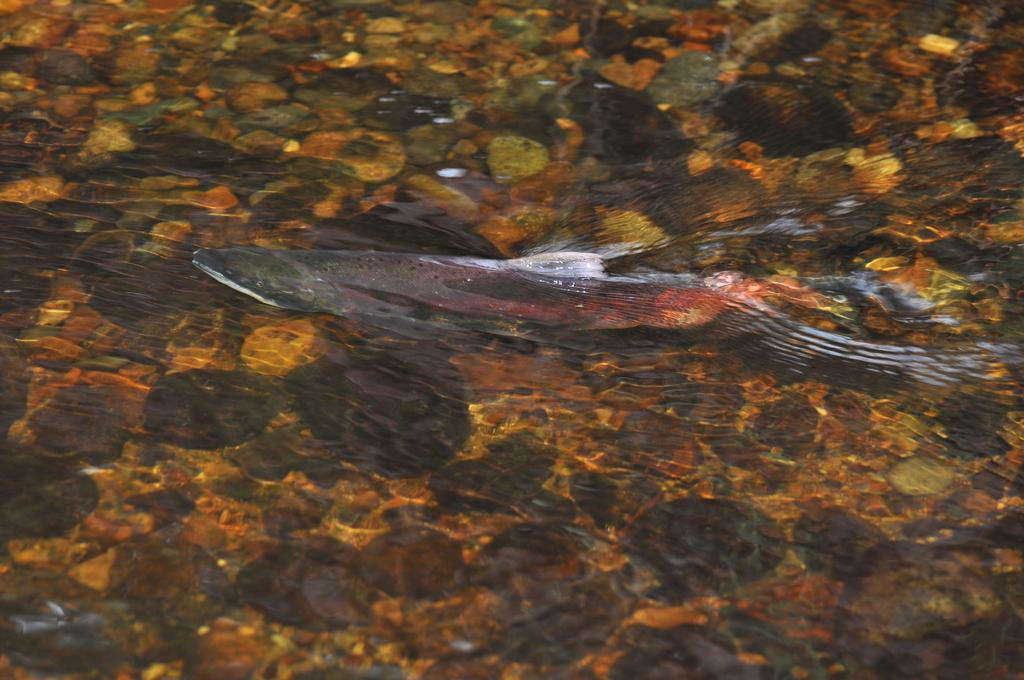What type of animal can be seen in the water in the image? There is a fish in the water in the image. What else can be seen in the water besides the fish? There are stones in the water in the image. How many cows are grazing near the water in the image? There are no cows present in the image; it only features a fish and stones in the water. 